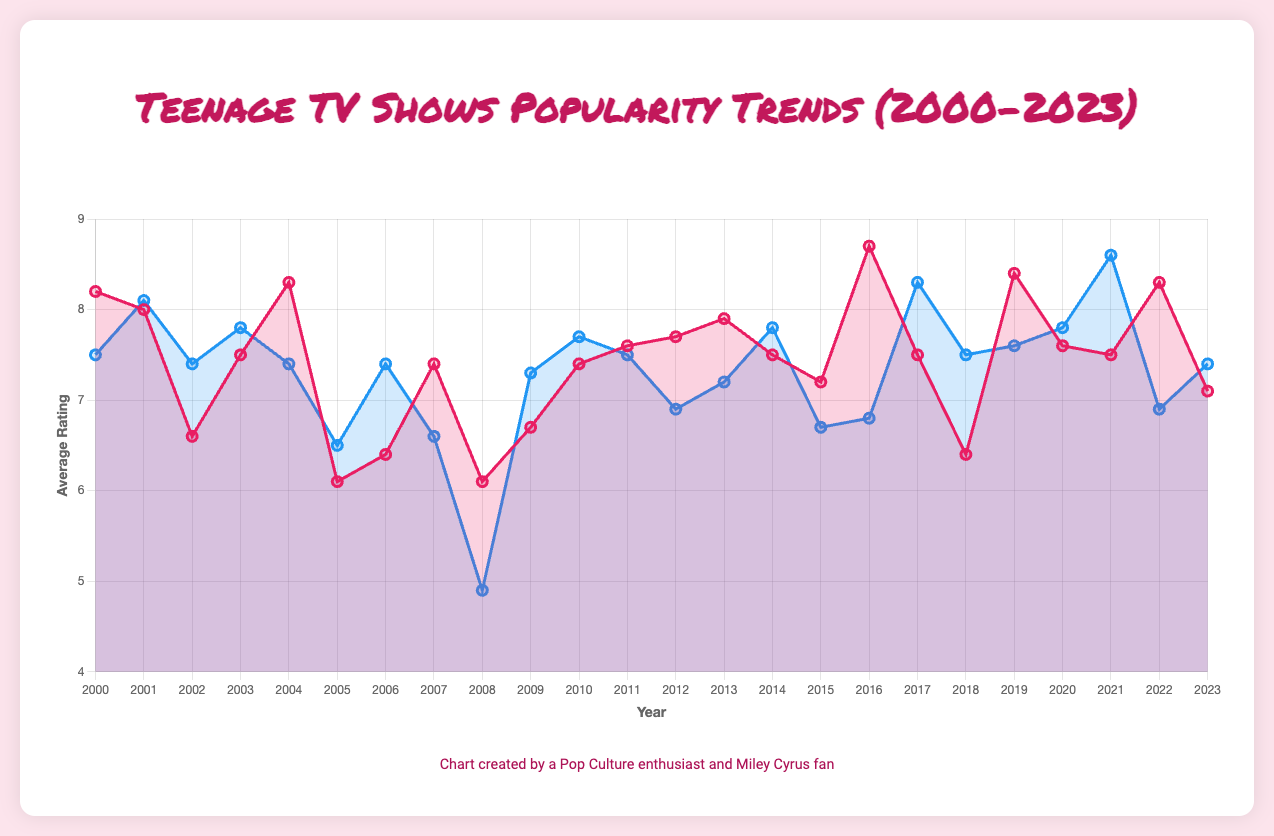What year had the highest average rating for all shows? To find the year with the highest average rating, we need to calculate the average ratings for each year by summing the average ratings of all shows for that year and dividing by the number of shows. Then, we compare these yearly averages to find the highest one.
Answer: 2016 What year did "Hannah Montana" air, and what was its average rating? First, identify the year "Hannah Montana" is listed and then check its average rating from the data.
Answer: 2006, 6.4 Which show has the highest average rating, and what year was it aired? Scan through the data to find the show with the highest average rating and note the corresponding year.
Answer: Stranger Things, 2016 What is the average rating difference between "Buffy the Vampire Slayer" in 2000 and "Stranger Things" in 2016? Identify the ratings for both shows: "Buffy the Vampire Slayer" in 2000 (8.2) and "Stranger Things" in 2016 (8.7). Subtract the former from the latter: 8.7 - 8.2 = 0.5.
Answer: 0.5 Compare the average rating of shows in 2006 and 2007. Which year had better ratings? Calculate the average rating for each year by adding the ratings of shows for that year and dividing by the number of shows. Compare the two averages. 2006: (6.4 + 7.4)/2 = 6.9; 2007: (7.4 + 6.6)/2 = 7.0.
Answer: 2007 What is the visual color used to represent "The Vampire Diaries" in the chart? Look for "The Vampire Diaries" in the legend of the chart and identify the associated line color.
Answer: Blue From 2000 to 2023, which year saw the largest drop in average rating between consecutive years? Calculate the difference in the average rating year by year and find the years with the largest negative change. Compare the differences: e.g., [(2000, 8.2 + 7.5)/2 - (2001, 8.0 + 8.1)/2, ... ].
Answer: 2008 How did the average rating for "Glee" compare to "10 Things I Hate About You" in 2009? Find the ratings for both shows in 2009: "Glee" (6.7) and "10 Things I Hate About You" (7.3). Compare the two values.
Answer: "10 Things I Hate About You" had a higher rating Identify the show with the lowest rating over the given years and specify the rating. Look through the data to find the show with the lowest rating and note down the rating.
Answer: "The Secret Life of the American Teenager", 4.9 Which year's average rating increased the most compared to the previous year? Calculate the year-over-year differences in average ratings and identify the one with the largest positive change. Subtract the averages: e.g., [(2001 avg) - (2000 avg), ...].
Answer: 2017 